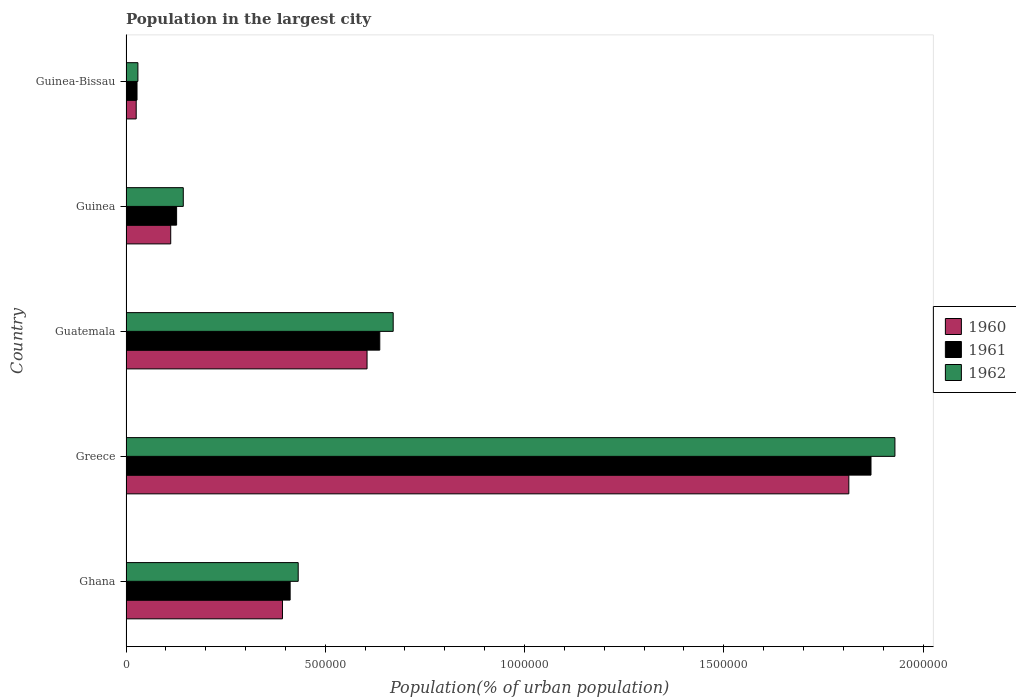How many groups of bars are there?
Offer a very short reply. 5. Are the number of bars on each tick of the Y-axis equal?
Provide a short and direct response. Yes. What is the label of the 3rd group of bars from the top?
Ensure brevity in your answer.  Guatemala. In how many cases, is the number of bars for a given country not equal to the number of legend labels?
Keep it short and to the point. 0. What is the population in the largest city in 1961 in Guinea?
Give a very brief answer. 1.27e+05. Across all countries, what is the maximum population in the largest city in 1960?
Give a very brief answer. 1.81e+06. Across all countries, what is the minimum population in the largest city in 1961?
Your answer should be very brief. 2.76e+04. In which country was the population in the largest city in 1960 maximum?
Keep it short and to the point. Greece. In which country was the population in the largest city in 1960 minimum?
Make the answer very short. Guinea-Bissau. What is the total population in the largest city in 1961 in the graph?
Provide a short and direct response. 3.07e+06. What is the difference between the population in the largest city in 1961 in Greece and that in Guatemala?
Your response must be concise. 1.23e+06. What is the difference between the population in the largest city in 1962 in Greece and the population in the largest city in 1960 in Guinea?
Keep it short and to the point. 1.82e+06. What is the average population in the largest city in 1960 per country?
Offer a very short reply. 5.90e+05. What is the difference between the population in the largest city in 1962 and population in the largest city in 1960 in Guinea?
Keep it short and to the point. 3.15e+04. What is the ratio of the population in the largest city in 1960 in Greece to that in Guinea-Bissau?
Provide a succinct answer. 70.93. Is the difference between the population in the largest city in 1962 in Ghana and Guinea greater than the difference between the population in the largest city in 1960 in Ghana and Guinea?
Offer a very short reply. Yes. What is the difference between the highest and the second highest population in the largest city in 1962?
Provide a succinct answer. 1.26e+06. What is the difference between the highest and the lowest population in the largest city in 1960?
Make the answer very short. 1.79e+06. In how many countries, is the population in the largest city in 1961 greater than the average population in the largest city in 1961 taken over all countries?
Provide a succinct answer. 2. Is the sum of the population in the largest city in 1960 in Ghana and Greece greater than the maximum population in the largest city in 1962 across all countries?
Your answer should be compact. Yes. What does the 2nd bar from the top in Guinea-Bissau represents?
Your response must be concise. 1961. What does the 1st bar from the bottom in Guatemala represents?
Offer a terse response. 1960. Is it the case that in every country, the sum of the population in the largest city in 1961 and population in the largest city in 1960 is greater than the population in the largest city in 1962?
Provide a short and direct response. Yes. How many bars are there?
Give a very brief answer. 15. Are all the bars in the graph horizontal?
Ensure brevity in your answer.  Yes. How many countries are there in the graph?
Your answer should be compact. 5. What is the difference between two consecutive major ticks on the X-axis?
Your answer should be very brief. 5.00e+05. Does the graph contain grids?
Offer a very short reply. No. Where does the legend appear in the graph?
Your answer should be very brief. Center right. How many legend labels are there?
Your answer should be compact. 3. How are the legend labels stacked?
Your answer should be compact. Vertical. What is the title of the graph?
Offer a very short reply. Population in the largest city. Does "1971" appear as one of the legend labels in the graph?
Your answer should be compact. No. What is the label or title of the X-axis?
Ensure brevity in your answer.  Population(% of urban population). What is the label or title of the Y-axis?
Give a very brief answer. Country. What is the Population(% of urban population) of 1960 in Ghana?
Make the answer very short. 3.93e+05. What is the Population(% of urban population) of 1961 in Ghana?
Provide a short and direct response. 4.12e+05. What is the Population(% of urban population) of 1962 in Ghana?
Offer a very short reply. 4.32e+05. What is the Population(% of urban population) of 1960 in Greece?
Your response must be concise. 1.81e+06. What is the Population(% of urban population) of 1961 in Greece?
Provide a succinct answer. 1.87e+06. What is the Population(% of urban population) in 1962 in Greece?
Make the answer very short. 1.93e+06. What is the Population(% of urban population) in 1960 in Guatemala?
Offer a terse response. 6.05e+05. What is the Population(% of urban population) of 1961 in Guatemala?
Your answer should be very brief. 6.37e+05. What is the Population(% of urban population) in 1962 in Guatemala?
Keep it short and to the point. 6.70e+05. What is the Population(% of urban population) in 1960 in Guinea?
Provide a succinct answer. 1.12e+05. What is the Population(% of urban population) in 1961 in Guinea?
Provide a short and direct response. 1.27e+05. What is the Population(% of urban population) of 1962 in Guinea?
Make the answer very short. 1.44e+05. What is the Population(% of urban population) of 1960 in Guinea-Bissau?
Offer a terse response. 2.56e+04. What is the Population(% of urban population) of 1961 in Guinea-Bissau?
Your answer should be very brief. 2.76e+04. What is the Population(% of urban population) of 1962 in Guinea-Bissau?
Give a very brief answer. 2.98e+04. Across all countries, what is the maximum Population(% of urban population) in 1960?
Offer a terse response. 1.81e+06. Across all countries, what is the maximum Population(% of urban population) in 1961?
Make the answer very short. 1.87e+06. Across all countries, what is the maximum Population(% of urban population) of 1962?
Your answer should be very brief. 1.93e+06. Across all countries, what is the minimum Population(% of urban population) in 1960?
Give a very brief answer. 2.56e+04. Across all countries, what is the minimum Population(% of urban population) of 1961?
Ensure brevity in your answer.  2.76e+04. Across all countries, what is the minimum Population(% of urban population) of 1962?
Your response must be concise. 2.98e+04. What is the total Population(% of urban population) in 1960 in the graph?
Keep it short and to the point. 2.95e+06. What is the total Population(% of urban population) in 1961 in the graph?
Your answer should be very brief. 3.07e+06. What is the total Population(% of urban population) in 1962 in the graph?
Provide a short and direct response. 3.21e+06. What is the difference between the Population(% of urban population) of 1960 in Ghana and that in Greece?
Provide a succinct answer. -1.42e+06. What is the difference between the Population(% of urban population) of 1961 in Ghana and that in Greece?
Your answer should be compact. -1.46e+06. What is the difference between the Population(% of urban population) of 1962 in Ghana and that in Greece?
Your answer should be compact. -1.50e+06. What is the difference between the Population(% of urban population) in 1960 in Ghana and that in Guatemala?
Ensure brevity in your answer.  -2.12e+05. What is the difference between the Population(% of urban population) of 1961 in Ghana and that in Guatemala?
Your answer should be very brief. -2.25e+05. What is the difference between the Population(% of urban population) in 1962 in Ghana and that in Guatemala?
Your response must be concise. -2.38e+05. What is the difference between the Population(% of urban population) in 1960 in Ghana and that in Guinea?
Your answer should be compact. 2.80e+05. What is the difference between the Population(% of urban population) in 1961 in Ghana and that in Guinea?
Ensure brevity in your answer.  2.85e+05. What is the difference between the Population(% of urban population) in 1962 in Ghana and that in Guinea?
Your response must be concise. 2.88e+05. What is the difference between the Population(% of urban population) of 1960 in Ghana and that in Guinea-Bissau?
Make the answer very short. 3.67e+05. What is the difference between the Population(% of urban population) of 1961 in Ghana and that in Guinea-Bissau?
Offer a terse response. 3.84e+05. What is the difference between the Population(% of urban population) in 1962 in Ghana and that in Guinea-Bissau?
Make the answer very short. 4.02e+05. What is the difference between the Population(% of urban population) of 1960 in Greece and that in Guatemala?
Give a very brief answer. 1.21e+06. What is the difference between the Population(% of urban population) of 1961 in Greece and that in Guatemala?
Offer a very short reply. 1.23e+06. What is the difference between the Population(% of urban population) in 1962 in Greece and that in Guatemala?
Provide a succinct answer. 1.26e+06. What is the difference between the Population(% of urban population) in 1960 in Greece and that in Guinea?
Your response must be concise. 1.70e+06. What is the difference between the Population(% of urban population) of 1961 in Greece and that in Guinea?
Keep it short and to the point. 1.74e+06. What is the difference between the Population(% of urban population) in 1962 in Greece and that in Guinea?
Your answer should be very brief. 1.79e+06. What is the difference between the Population(% of urban population) in 1960 in Greece and that in Guinea-Bissau?
Give a very brief answer. 1.79e+06. What is the difference between the Population(% of urban population) of 1961 in Greece and that in Guinea-Bissau?
Offer a terse response. 1.84e+06. What is the difference between the Population(% of urban population) of 1962 in Greece and that in Guinea-Bissau?
Provide a succinct answer. 1.90e+06. What is the difference between the Population(% of urban population) of 1960 in Guatemala and that in Guinea?
Keep it short and to the point. 4.93e+05. What is the difference between the Population(% of urban population) in 1961 in Guatemala and that in Guinea?
Your response must be concise. 5.10e+05. What is the difference between the Population(% of urban population) in 1962 in Guatemala and that in Guinea?
Offer a very short reply. 5.27e+05. What is the difference between the Population(% of urban population) in 1960 in Guatemala and that in Guinea-Bissau?
Your answer should be very brief. 5.79e+05. What is the difference between the Population(% of urban population) of 1961 in Guatemala and that in Guinea-Bissau?
Ensure brevity in your answer.  6.09e+05. What is the difference between the Population(% of urban population) of 1962 in Guatemala and that in Guinea-Bissau?
Your answer should be compact. 6.41e+05. What is the difference between the Population(% of urban population) in 1960 in Guinea and that in Guinea-Bissau?
Your answer should be very brief. 8.66e+04. What is the difference between the Population(% of urban population) of 1961 in Guinea and that in Guinea-Bissau?
Give a very brief answer. 9.93e+04. What is the difference between the Population(% of urban population) in 1962 in Guinea and that in Guinea-Bissau?
Provide a short and direct response. 1.14e+05. What is the difference between the Population(% of urban population) in 1960 in Ghana and the Population(% of urban population) in 1961 in Greece?
Your answer should be compact. -1.48e+06. What is the difference between the Population(% of urban population) in 1960 in Ghana and the Population(% of urban population) in 1962 in Greece?
Your answer should be compact. -1.54e+06. What is the difference between the Population(% of urban population) of 1961 in Ghana and the Population(% of urban population) of 1962 in Greece?
Ensure brevity in your answer.  -1.52e+06. What is the difference between the Population(% of urban population) of 1960 in Ghana and the Population(% of urban population) of 1961 in Guatemala?
Your response must be concise. -2.44e+05. What is the difference between the Population(% of urban population) of 1960 in Ghana and the Population(% of urban population) of 1962 in Guatemala?
Your answer should be very brief. -2.78e+05. What is the difference between the Population(% of urban population) in 1961 in Ghana and the Population(% of urban population) in 1962 in Guatemala?
Provide a succinct answer. -2.59e+05. What is the difference between the Population(% of urban population) in 1960 in Ghana and the Population(% of urban population) in 1961 in Guinea?
Ensure brevity in your answer.  2.66e+05. What is the difference between the Population(% of urban population) of 1960 in Ghana and the Population(% of urban population) of 1962 in Guinea?
Give a very brief answer. 2.49e+05. What is the difference between the Population(% of urban population) of 1961 in Ghana and the Population(% of urban population) of 1962 in Guinea?
Give a very brief answer. 2.68e+05. What is the difference between the Population(% of urban population) of 1960 in Ghana and the Population(% of urban population) of 1961 in Guinea-Bissau?
Keep it short and to the point. 3.65e+05. What is the difference between the Population(% of urban population) in 1960 in Ghana and the Population(% of urban population) in 1962 in Guinea-Bissau?
Provide a succinct answer. 3.63e+05. What is the difference between the Population(% of urban population) in 1961 in Ghana and the Population(% of urban population) in 1962 in Guinea-Bissau?
Ensure brevity in your answer.  3.82e+05. What is the difference between the Population(% of urban population) in 1960 in Greece and the Population(% of urban population) in 1961 in Guatemala?
Keep it short and to the point. 1.18e+06. What is the difference between the Population(% of urban population) of 1960 in Greece and the Population(% of urban population) of 1962 in Guatemala?
Your answer should be compact. 1.14e+06. What is the difference between the Population(% of urban population) in 1961 in Greece and the Population(% of urban population) in 1962 in Guatemala?
Provide a succinct answer. 1.20e+06. What is the difference between the Population(% of urban population) of 1960 in Greece and the Population(% of urban population) of 1961 in Guinea?
Provide a succinct answer. 1.69e+06. What is the difference between the Population(% of urban population) in 1960 in Greece and the Population(% of urban population) in 1962 in Guinea?
Offer a terse response. 1.67e+06. What is the difference between the Population(% of urban population) in 1961 in Greece and the Population(% of urban population) in 1962 in Guinea?
Give a very brief answer. 1.73e+06. What is the difference between the Population(% of urban population) in 1960 in Greece and the Population(% of urban population) in 1961 in Guinea-Bissau?
Give a very brief answer. 1.79e+06. What is the difference between the Population(% of urban population) in 1960 in Greece and the Population(% of urban population) in 1962 in Guinea-Bissau?
Give a very brief answer. 1.78e+06. What is the difference between the Population(% of urban population) in 1961 in Greece and the Population(% of urban population) in 1962 in Guinea-Bissau?
Make the answer very short. 1.84e+06. What is the difference between the Population(% of urban population) in 1960 in Guatemala and the Population(% of urban population) in 1961 in Guinea?
Offer a terse response. 4.78e+05. What is the difference between the Population(% of urban population) in 1960 in Guatemala and the Population(% of urban population) in 1962 in Guinea?
Give a very brief answer. 4.61e+05. What is the difference between the Population(% of urban population) of 1961 in Guatemala and the Population(% of urban population) of 1962 in Guinea?
Provide a short and direct response. 4.93e+05. What is the difference between the Population(% of urban population) in 1960 in Guatemala and the Population(% of urban population) in 1961 in Guinea-Bissau?
Keep it short and to the point. 5.77e+05. What is the difference between the Population(% of urban population) in 1960 in Guatemala and the Population(% of urban population) in 1962 in Guinea-Bissau?
Your response must be concise. 5.75e+05. What is the difference between the Population(% of urban population) in 1961 in Guatemala and the Population(% of urban population) in 1962 in Guinea-Bissau?
Ensure brevity in your answer.  6.07e+05. What is the difference between the Population(% of urban population) of 1960 in Guinea and the Population(% of urban population) of 1961 in Guinea-Bissau?
Your answer should be very brief. 8.45e+04. What is the difference between the Population(% of urban population) in 1960 in Guinea and the Population(% of urban population) in 1962 in Guinea-Bissau?
Provide a short and direct response. 8.23e+04. What is the difference between the Population(% of urban population) in 1961 in Guinea and the Population(% of urban population) in 1962 in Guinea-Bissau?
Your answer should be compact. 9.71e+04. What is the average Population(% of urban population) of 1960 per country?
Your response must be concise. 5.90e+05. What is the average Population(% of urban population) in 1961 per country?
Provide a succinct answer. 6.14e+05. What is the average Population(% of urban population) in 1962 per country?
Provide a short and direct response. 6.41e+05. What is the difference between the Population(% of urban population) in 1960 and Population(% of urban population) in 1961 in Ghana?
Offer a very short reply. -1.93e+04. What is the difference between the Population(% of urban population) of 1960 and Population(% of urban population) of 1962 in Ghana?
Give a very brief answer. -3.95e+04. What is the difference between the Population(% of urban population) of 1961 and Population(% of urban population) of 1962 in Ghana?
Your answer should be compact. -2.02e+04. What is the difference between the Population(% of urban population) in 1960 and Population(% of urban population) in 1961 in Greece?
Offer a very short reply. -5.56e+04. What is the difference between the Population(% of urban population) of 1960 and Population(% of urban population) of 1962 in Greece?
Your answer should be compact. -1.16e+05. What is the difference between the Population(% of urban population) of 1961 and Population(% of urban population) of 1962 in Greece?
Provide a succinct answer. -6.00e+04. What is the difference between the Population(% of urban population) in 1960 and Population(% of urban population) in 1961 in Guatemala?
Ensure brevity in your answer.  -3.19e+04. What is the difference between the Population(% of urban population) in 1960 and Population(% of urban population) in 1962 in Guatemala?
Provide a short and direct response. -6.56e+04. What is the difference between the Population(% of urban population) of 1961 and Population(% of urban population) of 1962 in Guatemala?
Provide a succinct answer. -3.37e+04. What is the difference between the Population(% of urban population) in 1960 and Population(% of urban population) in 1961 in Guinea?
Offer a terse response. -1.48e+04. What is the difference between the Population(% of urban population) of 1960 and Population(% of urban population) of 1962 in Guinea?
Offer a very short reply. -3.15e+04. What is the difference between the Population(% of urban population) of 1961 and Population(% of urban population) of 1962 in Guinea?
Ensure brevity in your answer.  -1.68e+04. What is the difference between the Population(% of urban population) in 1960 and Population(% of urban population) in 1961 in Guinea-Bissau?
Make the answer very short. -2047. What is the difference between the Population(% of urban population) of 1960 and Population(% of urban population) of 1962 in Guinea-Bissau?
Provide a short and direct response. -4261. What is the difference between the Population(% of urban population) of 1961 and Population(% of urban population) of 1962 in Guinea-Bissau?
Ensure brevity in your answer.  -2214. What is the ratio of the Population(% of urban population) in 1960 in Ghana to that in Greece?
Your answer should be compact. 0.22. What is the ratio of the Population(% of urban population) of 1961 in Ghana to that in Greece?
Offer a very short reply. 0.22. What is the ratio of the Population(% of urban population) in 1962 in Ghana to that in Greece?
Your answer should be very brief. 0.22. What is the ratio of the Population(% of urban population) in 1960 in Ghana to that in Guatemala?
Make the answer very short. 0.65. What is the ratio of the Population(% of urban population) in 1961 in Ghana to that in Guatemala?
Offer a terse response. 0.65. What is the ratio of the Population(% of urban population) of 1962 in Ghana to that in Guatemala?
Provide a short and direct response. 0.64. What is the ratio of the Population(% of urban population) of 1960 in Ghana to that in Guinea?
Your answer should be very brief. 3.5. What is the ratio of the Population(% of urban population) of 1961 in Ghana to that in Guinea?
Offer a terse response. 3.24. What is the ratio of the Population(% of urban population) of 1962 in Ghana to that in Guinea?
Your response must be concise. 3.01. What is the ratio of the Population(% of urban population) in 1960 in Ghana to that in Guinea-Bissau?
Offer a very short reply. 15.35. What is the ratio of the Population(% of urban population) of 1961 in Ghana to that in Guinea-Bissau?
Provide a short and direct response. 14.91. What is the ratio of the Population(% of urban population) of 1962 in Ghana to that in Guinea-Bissau?
Provide a succinct answer. 14.48. What is the ratio of the Population(% of urban population) in 1960 in Greece to that in Guatemala?
Give a very brief answer. 3. What is the ratio of the Population(% of urban population) of 1961 in Greece to that in Guatemala?
Your response must be concise. 2.94. What is the ratio of the Population(% of urban population) of 1962 in Greece to that in Guatemala?
Provide a short and direct response. 2.88. What is the ratio of the Population(% of urban population) in 1960 in Greece to that in Guinea?
Offer a terse response. 16.17. What is the ratio of the Population(% of urban population) of 1961 in Greece to that in Guinea?
Offer a very short reply. 14.73. What is the ratio of the Population(% of urban population) of 1962 in Greece to that in Guinea?
Ensure brevity in your answer.  13.43. What is the ratio of the Population(% of urban population) of 1960 in Greece to that in Guinea-Bissau?
Make the answer very short. 70.93. What is the ratio of the Population(% of urban population) in 1961 in Greece to that in Guinea-Bissau?
Your answer should be compact. 67.69. What is the ratio of the Population(% of urban population) in 1962 in Greece to that in Guinea-Bissau?
Your answer should be very brief. 64.68. What is the ratio of the Population(% of urban population) of 1960 in Guatemala to that in Guinea?
Keep it short and to the point. 5.39. What is the ratio of the Population(% of urban population) of 1961 in Guatemala to that in Guinea?
Keep it short and to the point. 5.02. What is the ratio of the Population(% of urban population) in 1962 in Guatemala to that in Guinea?
Offer a terse response. 4.67. What is the ratio of the Population(% of urban population) of 1960 in Guatemala to that in Guinea-Bissau?
Your response must be concise. 23.65. What is the ratio of the Population(% of urban population) of 1961 in Guatemala to that in Guinea-Bissau?
Your answer should be very brief. 23.06. What is the ratio of the Population(% of urban population) in 1962 in Guatemala to that in Guinea-Bissau?
Provide a succinct answer. 22.47. What is the ratio of the Population(% of urban population) in 1960 in Guinea to that in Guinea-Bissau?
Give a very brief answer. 4.39. What is the ratio of the Population(% of urban population) of 1961 in Guinea to that in Guinea-Bissau?
Your answer should be compact. 4.6. What is the ratio of the Population(% of urban population) of 1962 in Guinea to that in Guinea-Bissau?
Your answer should be compact. 4.82. What is the difference between the highest and the second highest Population(% of urban population) of 1960?
Offer a very short reply. 1.21e+06. What is the difference between the highest and the second highest Population(% of urban population) of 1961?
Offer a terse response. 1.23e+06. What is the difference between the highest and the second highest Population(% of urban population) of 1962?
Provide a succinct answer. 1.26e+06. What is the difference between the highest and the lowest Population(% of urban population) in 1960?
Your answer should be very brief. 1.79e+06. What is the difference between the highest and the lowest Population(% of urban population) of 1961?
Your answer should be compact. 1.84e+06. What is the difference between the highest and the lowest Population(% of urban population) in 1962?
Provide a succinct answer. 1.90e+06. 